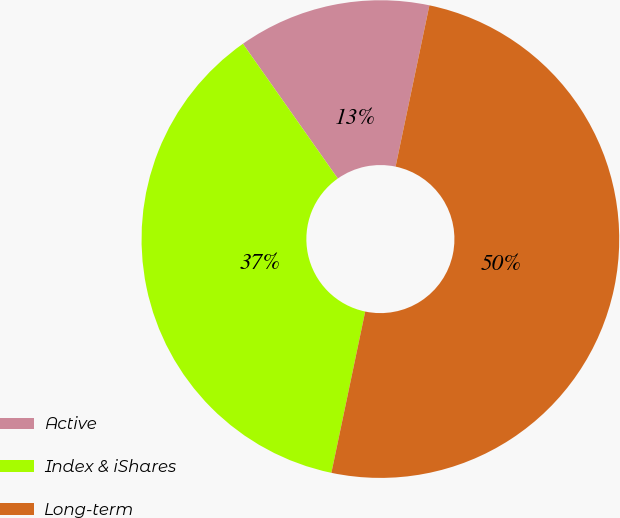Convert chart. <chart><loc_0><loc_0><loc_500><loc_500><pie_chart><fcel>Active<fcel>Index & iShares<fcel>Long-term<nl><fcel>13.05%<fcel>36.95%<fcel>50.0%<nl></chart> 